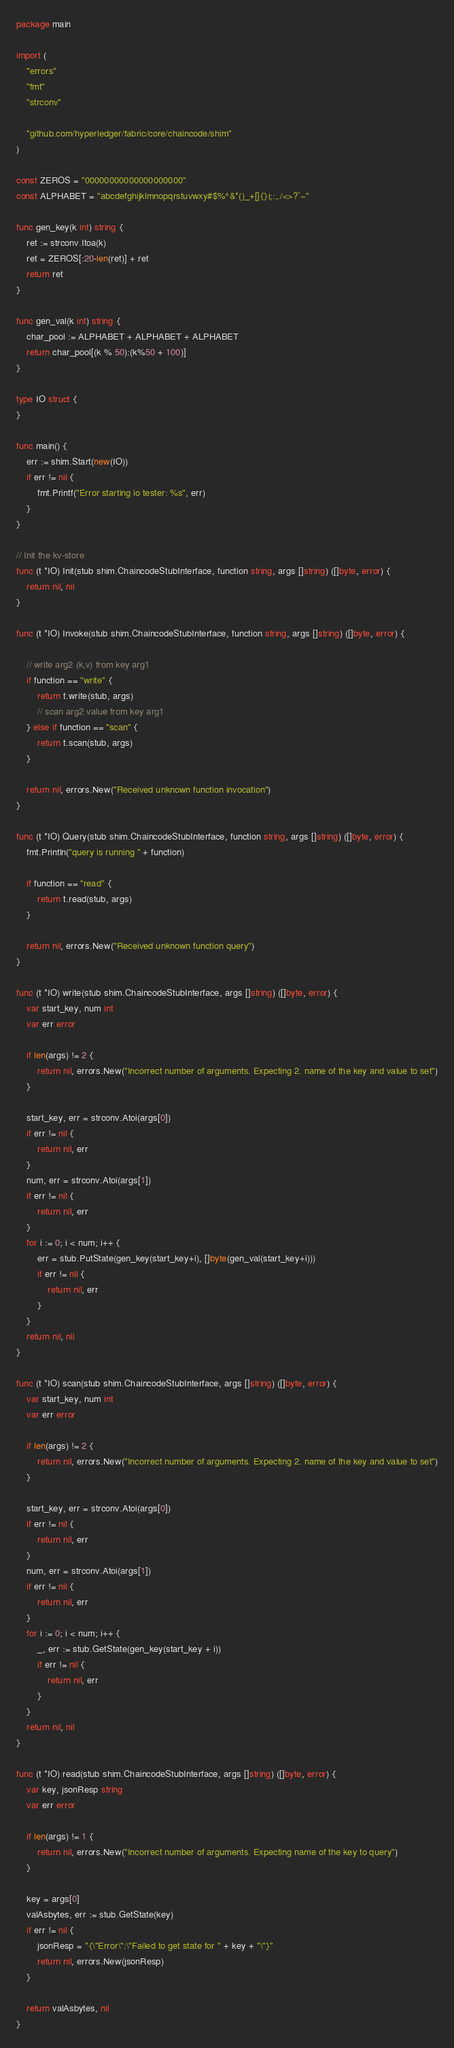<code> <loc_0><loc_0><loc_500><loc_500><_Go_>package main

import (
	"errors"
	"fmt"
	"strconv"

	"github.com/hyperledger/fabric/core/chaincode/shim"
)

const ZEROS = "00000000000000000000"
const ALPHABET = "abcdefghijklmnopqrstuvwxy#$%^&*()_+[]{}|;:,./<>?`~"

func gen_key(k int) string {
	ret := strconv.Itoa(k)
	ret = ZEROS[:20-len(ret)] + ret
	return ret
}

func gen_val(k int) string {
	char_pool := ALPHABET + ALPHABET + ALPHABET
	return char_pool[(k % 50):(k%50 + 100)]
}

type IO struct {
}

func main() {
	err := shim.Start(new(IO))
	if err != nil {
		fmt.Printf("Error starting io tester: %s", err)
	}
}

// Init the kv-store
func (t *IO) Init(stub shim.ChaincodeStubInterface, function string, args []string) ([]byte, error) {
	return nil, nil
}

func (t *IO) Invoke(stub shim.ChaincodeStubInterface, function string, args []string) ([]byte, error) {

	// write arg2 (k,v) from key arg1
	if function == "write" {
		return t.write(stub, args)
		// scan arg2 value from key arg1
	} else if function == "scan" {
		return t.scan(stub, args)
	}

	return nil, errors.New("Received unknown function invocation")
}

func (t *IO) Query(stub shim.ChaincodeStubInterface, function string, args []string) ([]byte, error) {
	fmt.Println("query is running " + function)

	if function == "read" {
		return t.read(stub, args)
	}

	return nil, errors.New("Received unknown function query")
}

func (t *IO) write(stub shim.ChaincodeStubInterface, args []string) ([]byte, error) {
	var start_key, num int
	var err error

	if len(args) != 2 {
		return nil, errors.New("Incorrect number of arguments. Expecting 2. name of the key and value to set")
	}

	start_key, err = strconv.Atoi(args[0])
	if err != nil {
		return nil, err
	}
	num, err = strconv.Atoi(args[1])
	if err != nil {
		return nil, err
	}
	for i := 0; i < num; i++ {
		err = stub.PutState(gen_key(start_key+i), []byte(gen_val(start_key+i)))
		if err != nil {
			return nil, err
		}
	}
	return nil, nil
}

func (t *IO) scan(stub shim.ChaincodeStubInterface, args []string) ([]byte, error) {
	var start_key, num int
	var err error

	if len(args) != 2 {
		return nil, errors.New("Incorrect number of arguments. Expecting 2. name of the key and value to set")
	}

	start_key, err = strconv.Atoi(args[0])
	if err != nil {
		return nil, err
	}
	num, err = strconv.Atoi(args[1])
	if err != nil {
		return nil, err
	}
	for i := 0; i < num; i++ {
		_, err := stub.GetState(gen_key(start_key + i))
		if err != nil {
			return nil, err
		}
	}
	return nil, nil
}

func (t *IO) read(stub shim.ChaincodeStubInterface, args []string) ([]byte, error) {
	var key, jsonResp string
	var err error

	if len(args) != 1 {
		return nil, errors.New("Incorrect number of arguments. Expecting name of the key to query")
	}

	key = args[0]
	valAsbytes, err := stub.GetState(key)
	if err != nil {
		jsonResp = "{\"Error\":\"Failed to get state for " + key + "\"}"
		return nil, errors.New(jsonResp)
	}

	return valAsbytes, nil
}
</code> 